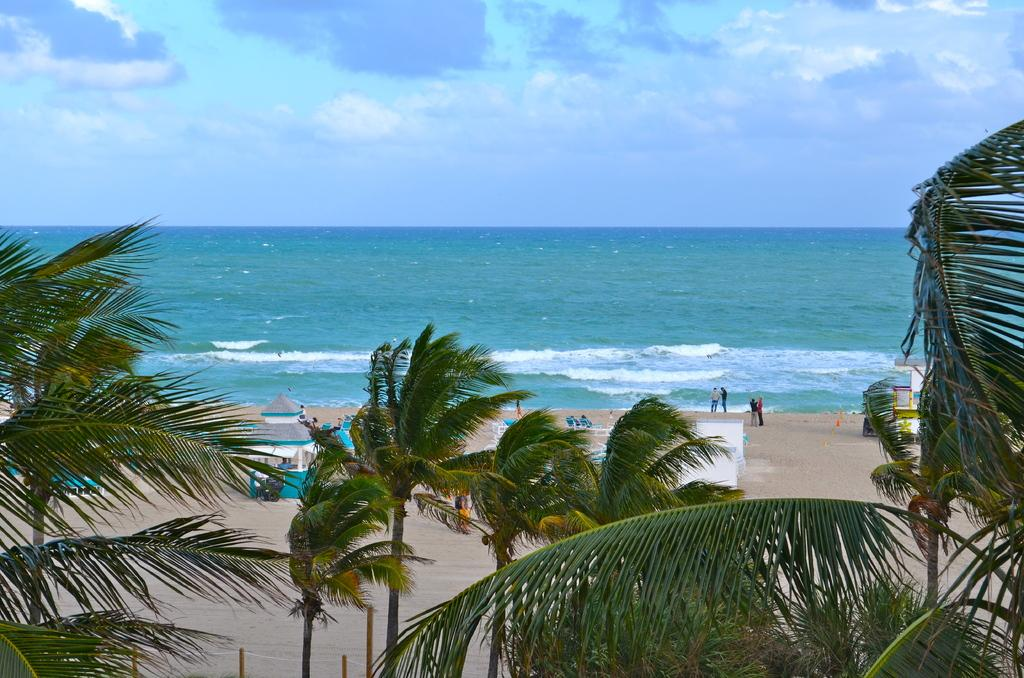What type of natural elements can be seen in the image? There are trees visible in the image. What type of man-made structures can be seen in the image? There are buildings visible in the image. Are there any living beings present in the image? Yes, there are people visible in the image. What type of water feature can be seen in the image? There is water visible in the image. What part of the natural environment is visible in the image? The sky is visible in the image. What type of weather can be inferred from the image? The presence of clouds in the image suggests that it might be a partly cloudy day. What type of news is being broadcasted on the radio in the image? There is no radio or news broadcast present in the image. How much payment is being exchanged between the people in the image? There is no payment being exchanged between the people in the image. 